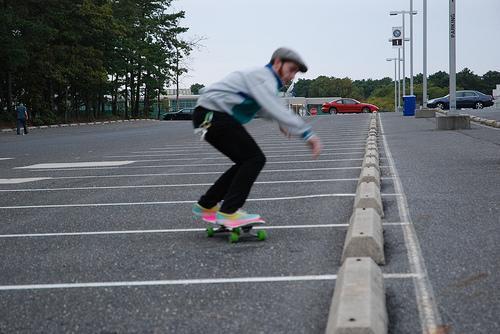How many people are skateboarding?
Give a very brief answer. 1. How many vehicles behind the skateborder are red?
Give a very brief answer. 1. 